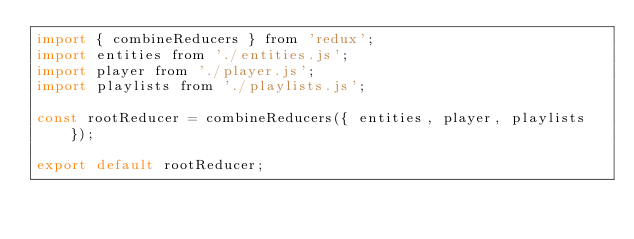Convert code to text. <code><loc_0><loc_0><loc_500><loc_500><_JavaScript_>import { combineReducers } from 'redux';
import entities from './entities.js';
import player from './player.js';
import playlists from './playlists.js';

const rootReducer = combineReducers({ entities, player, playlists });

export default rootReducer;
</code> 